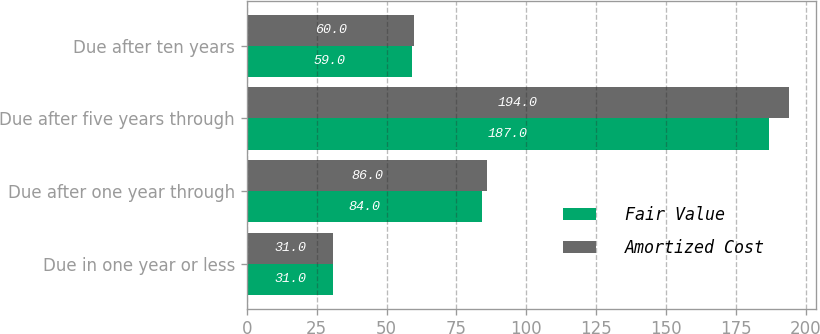Convert chart. <chart><loc_0><loc_0><loc_500><loc_500><stacked_bar_chart><ecel><fcel>Due in one year or less<fcel>Due after one year through<fcel>Due after five years through<fcel>Due after ten years<nl><fcel>Fair Value<fcel>31<fcel>84<fcel>187<fcel>59<nl><fcel>Amortized Cost<fcel>31<fcel>86<fcel>194<fcel>60<nl></chart> 